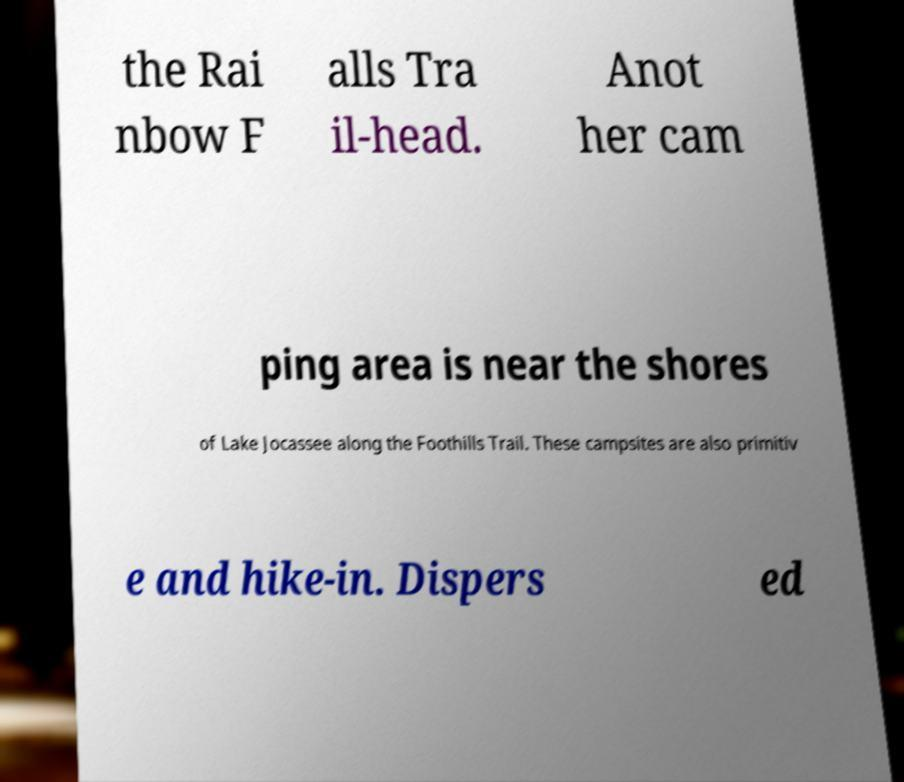Could you assist in decoding the text presented in this image and type it out clearly? the Rai nbow F alls Tra il-head. Anot her cam ping area is near the shores of Lake Jocassee along the Foothills Trail. These campsites are also primitiv e and hike-in. Dispers ed 